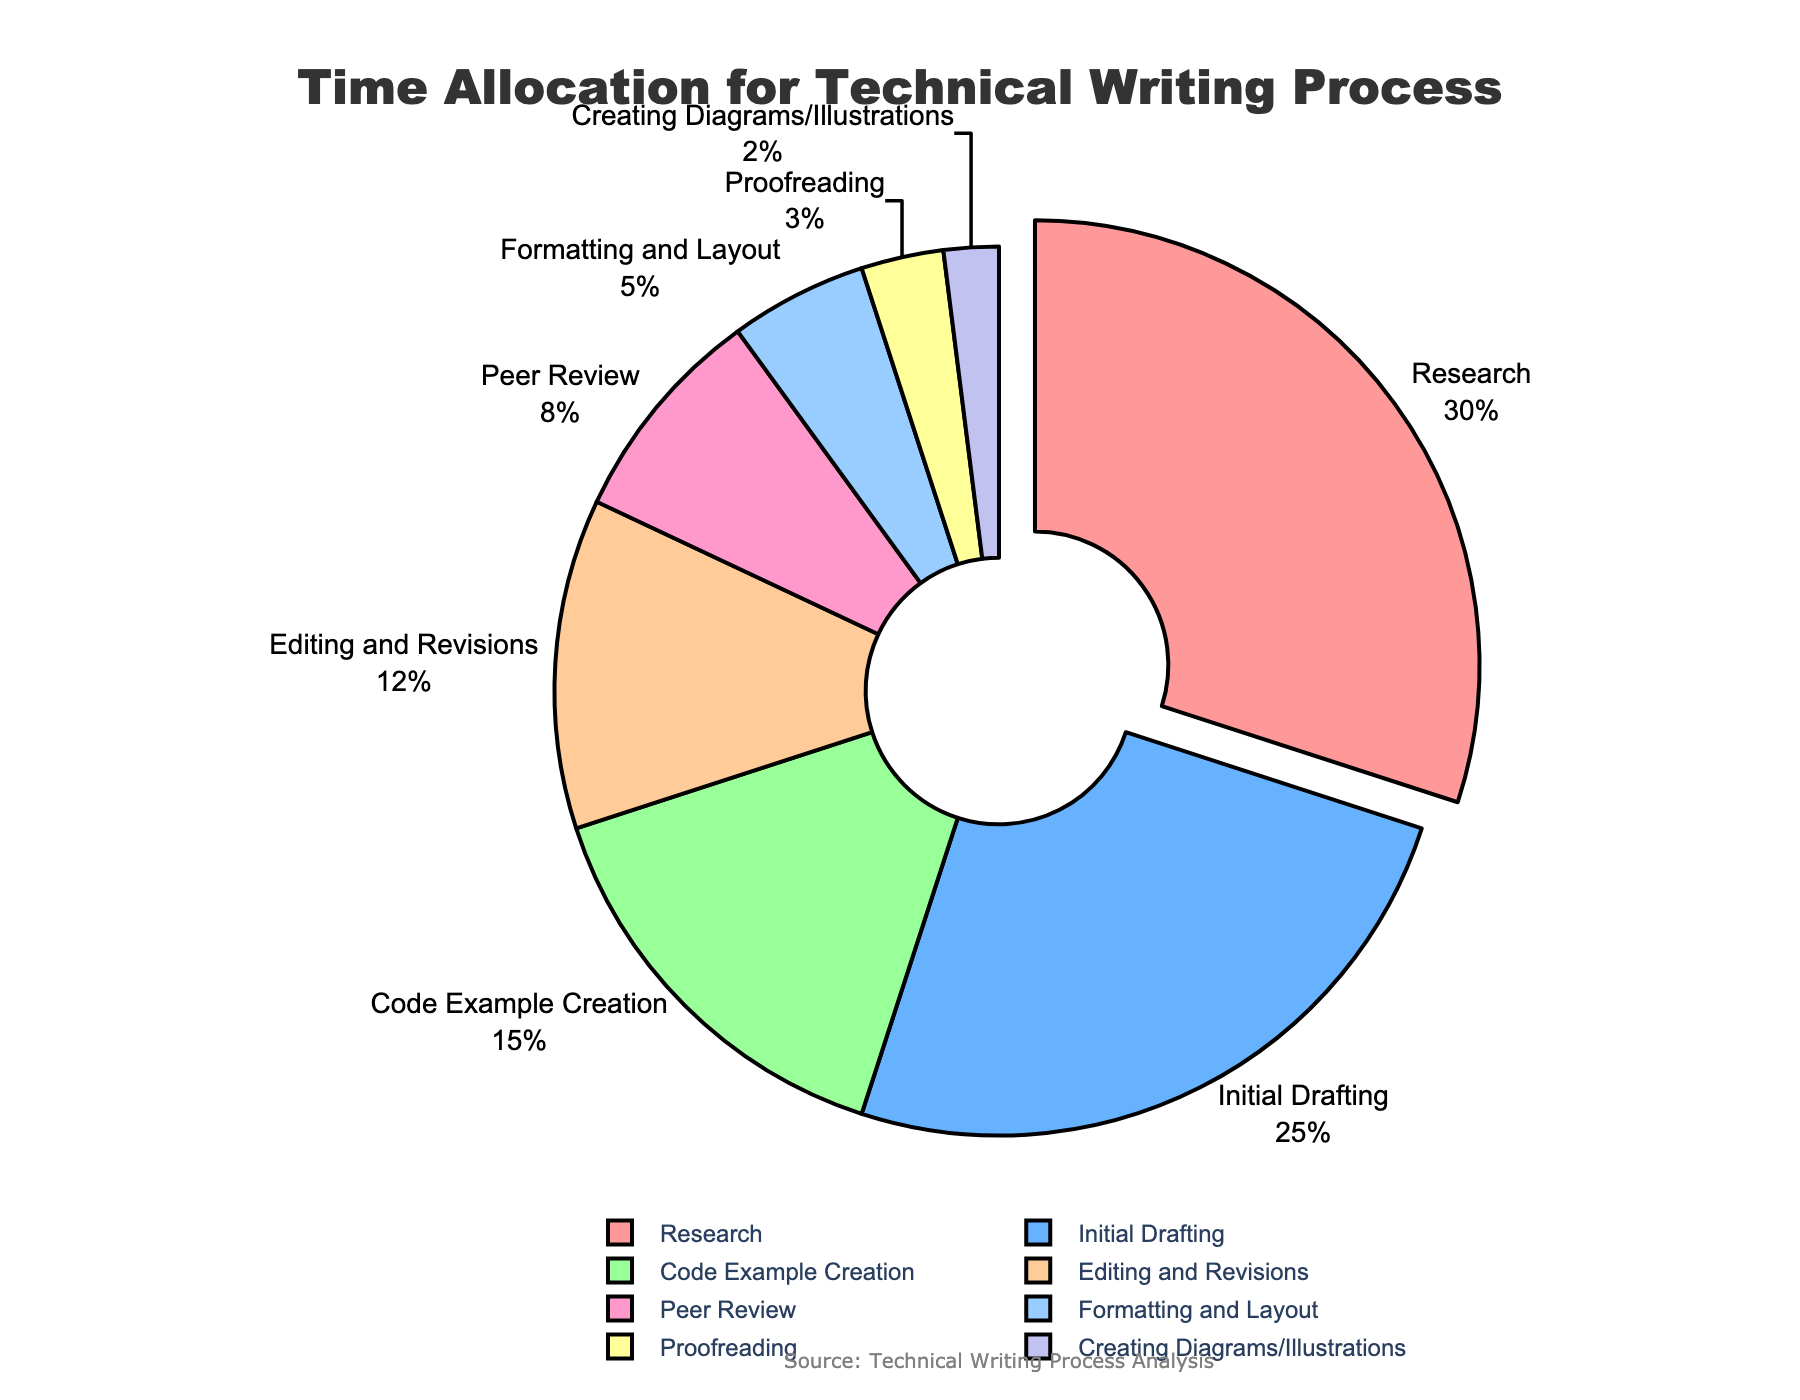Which stage of the technical writing process takes up the largest portion of time? First, identify all the stages listed in the chart. Then, find the stage with the highest percentage. From the data, we can see that Research has the highest value at 30%.
Answer: Research What is the combined percentage of time spent on Peer Review, Formatting and Layout, and Proofreading? Add the percentages for Peer Review (8%), Formatting and Layout (5%), and Proofreading (3%). The sum will give the combined percentage. So, 8 + 5 + 3 = 16%.
Answer: 16% How much more time is allocated to Research compared to Initial Drafting? Subtract the percentage for Initial Drafting (25%) from the percentage for Research (30%). So, 30 - 25 = 5%.
Answer: 5% Which stage takes the least amount of time, and what is that percentage? Identify all the stages and their corresponding percentages from the chart. The smallest value is Creating Diagrams/Illustrations at 2%.
Answer: Creating Diagrams/Illustrations, 2% What is the average percentage of time spent on Editing and Revisions and Peer Review combined? First, add the percentages for Editing and Revisions (12%) and Peer Review (8%). The sum is 12 + 8 = 20%. Then, divide by 2 to find the average, 20 / 2 = 10%.
Answer: 10% How many stages have allocated time less than 10%? Identify the stages with values less than 10% from the chart. These are Peer Review (8%), Formatting and Layout (5%), Proofreading (3%), and Creating Diagrams/Illustrations (2%), making a total of 4 stages.
Answer: 4 Which two stages together take up as much time as Research? Look for two stages whose combined total is 30%. Initial Drafting (25%) and Creating Diagrams/Illustrations (2%) together give 27%, but Code Example Creation (15%) and Editing and Revisions (12%) together give 27%. The closest match without exceeding is Initial Drafting (25%) plus Proofreading (3%) equals 28%, subtotal closest to 30%.
Answer: Initial Drafting, Proofreading Of the stages represented by the color blue, which one has the higher percentage and what is that percentage? From the color information provided, identify the stages represented by shades of blue and their corresponding percentages. Determine which of these has the higher percentage. This would require examining the visual chart, but given the colors listed, assuming #66B2FF (light blue) and #99CCFF, detect the colors in the context.
Answer: Formatting and Layout, 5% (Hypothetically assigned value) If the time spent on Code Example Creation were doubled, what percentage of the total process would it represent? First, find the current percentage for Code Example Creation (15%). Doubling it results in 15 * 2 = 30%. This new value would mean Code Example Creation takes 30% of the total time, similar to the highest percentage currently for Research.
Answer: 30% Is there more time allocated to Peer Review or Formatting and Layout, and by how much? Compare the values for Peer Review (8%) and Formatting and Layout (5%). Subtract the smaller value from the larger: 8 - 5 = 3%.
Answer: Peer Review by 3% 